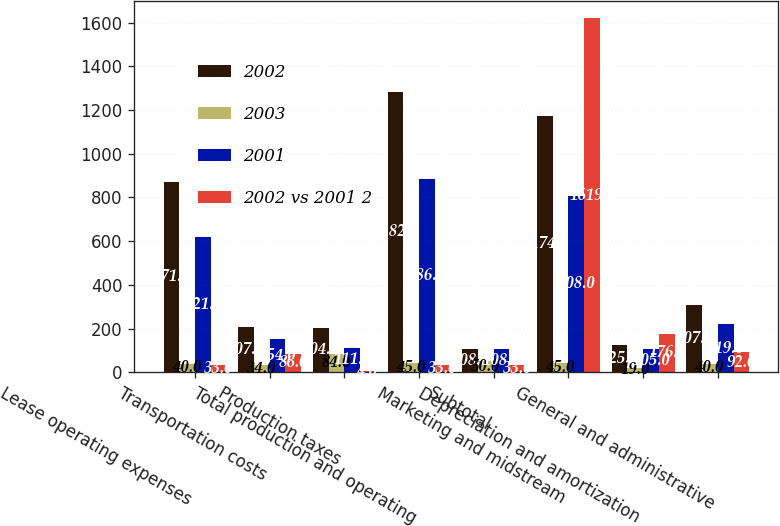Convert chart to OTSL. <chart><loc_0><loc_0><loc_500><loc_500><stacked_bar_chart><ecel><fcel>Lease operating expenses<fcel>Transportation costs<fcel>Production taxes<fcel>Total production and operating<fcel>Subtotal<fcel>Marketing and midstream<fcel>Depreciation and amortization<fcel>General and administrative<nl><fcel>2002<fcel>871<fcel>207<fcel>204<fcel>1282<fcel>108<fcel>1174<fcel>125<fcel>307<nl><fcel>2003<fcel>40<fcel>34<fcel>84<fcel>45<fcel>50<fcel>45<fcel>19<fcel>40<nl><fcel>2001<fcel>621<fcel>154<fcel>111<fcel>886<fcel>108<fcel>808<fcel>105<fcel>219<nl><fcel>2002 vs 2001 2<fcel>33<fcel>86<fcel>4<fcel>33<fcel>33<fcel>1619<fcel>176<fcel>92<nl></chart> 